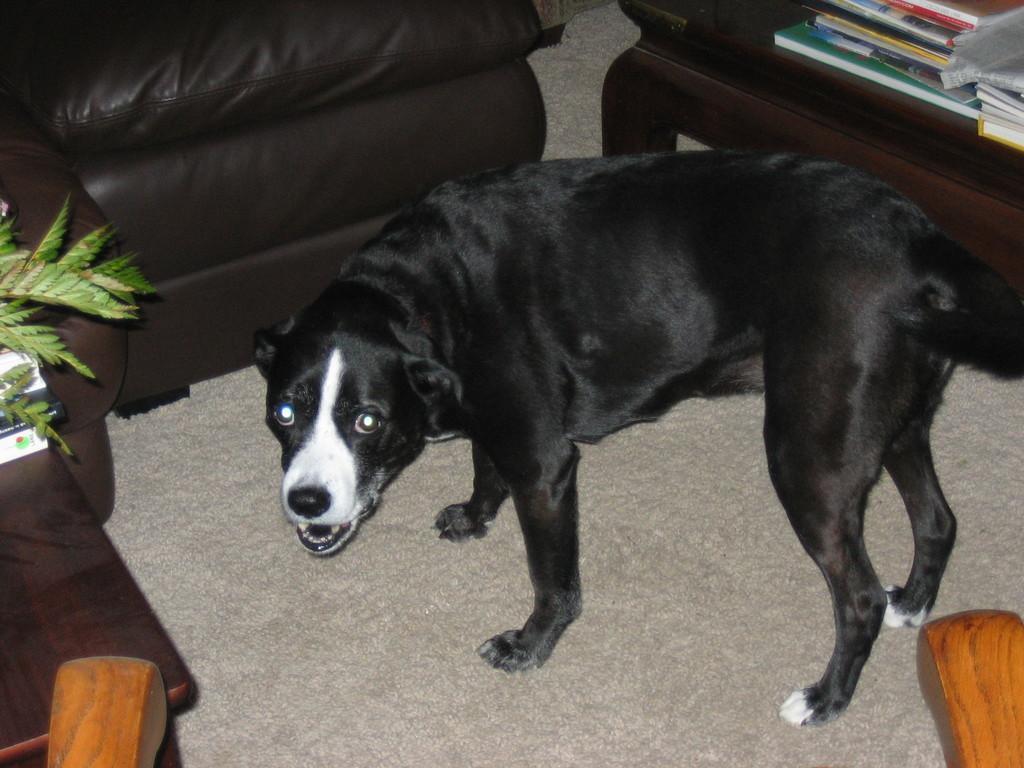Can you describe this image briefly? This image consists of a dog ,sofas ,table. On the top right corner there is a table and books placed on it. On the left side top corner there is a sofa and left side bottom corner there is a table and books placed on that table. This dog is in the middle of the image it is in black colour. There might be a sofa in the bottom side. 